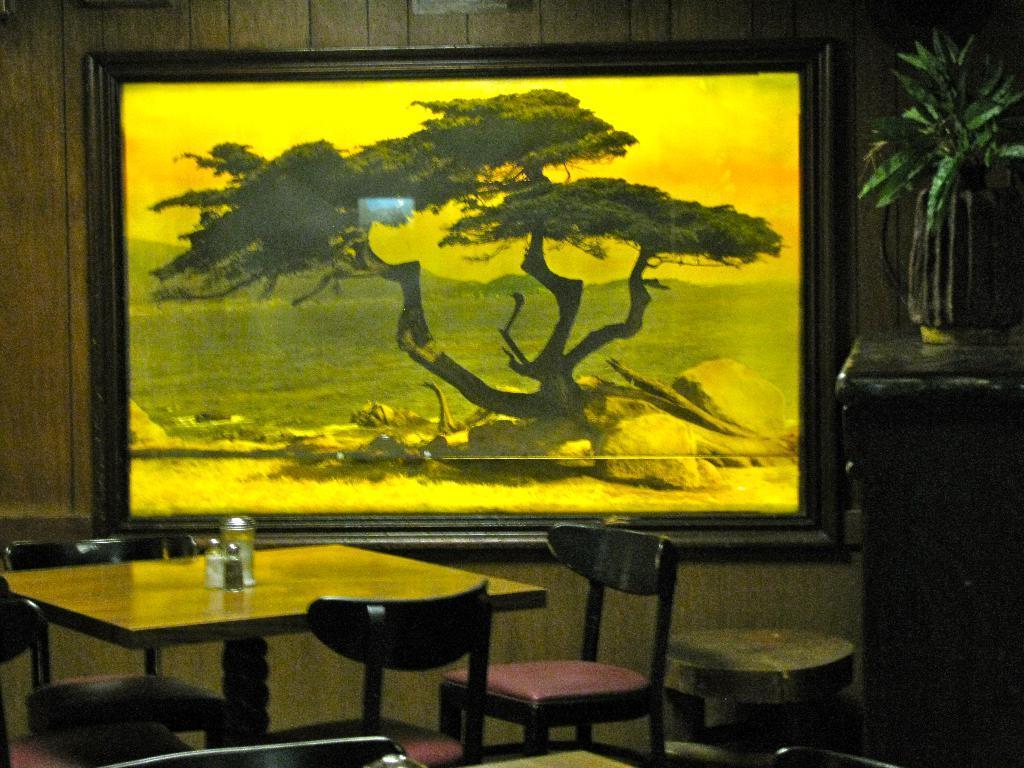In one or two sentences, can you explain what this image depicts? In this image i can see a table, a board with few chairs. l 